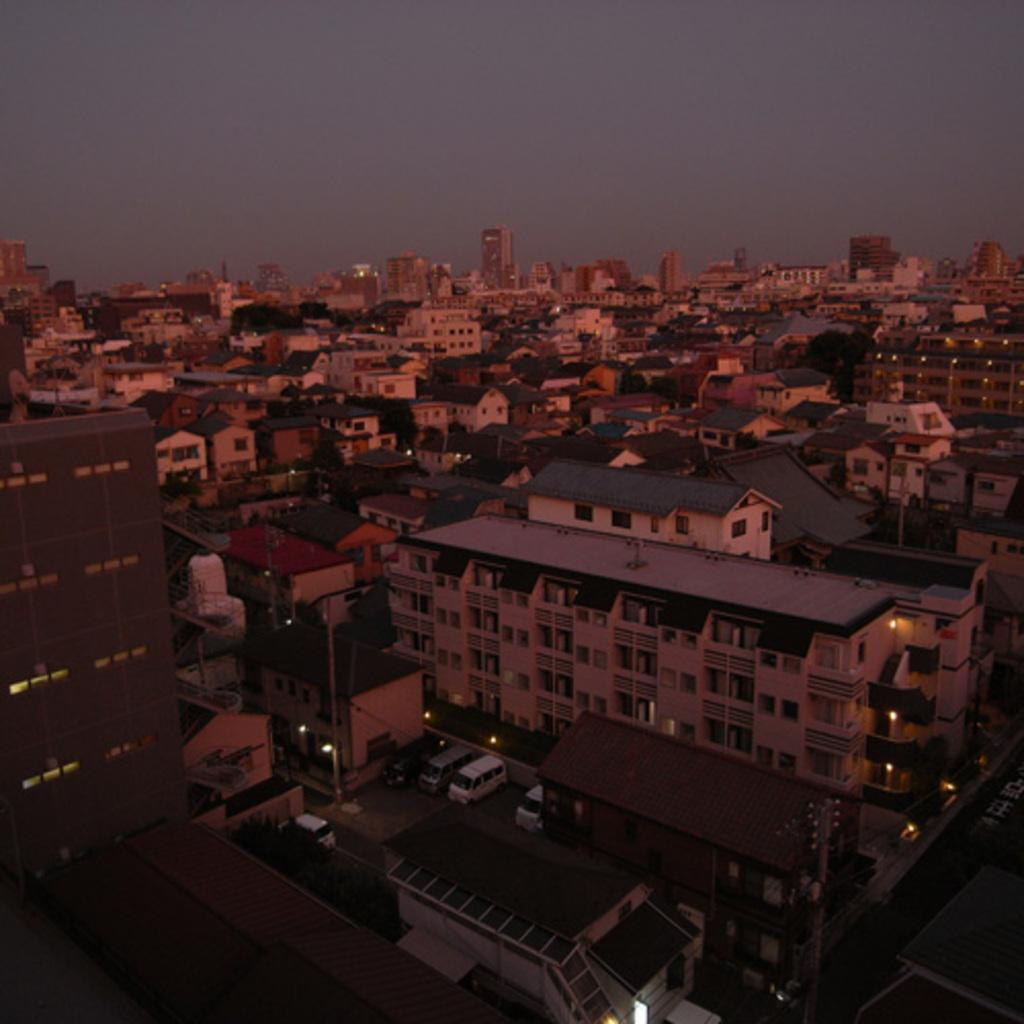What is the perspective of the image? The image shows a top view of a city. At what time of day is the image set? The image is set during the evening. What type of buildings can be seen in the image? There are houses in the image. What else can be seen moving in the image? There are vehicles in the image. What type of infrastructure is present in the image? There are roads in the image. What natural elements are present in the image? There are trees in the image. How does the hat adjust to the changing temperature in the image? There is no hat present in the image, so it is not possible to determine how it would adjust to changing temperatures. 